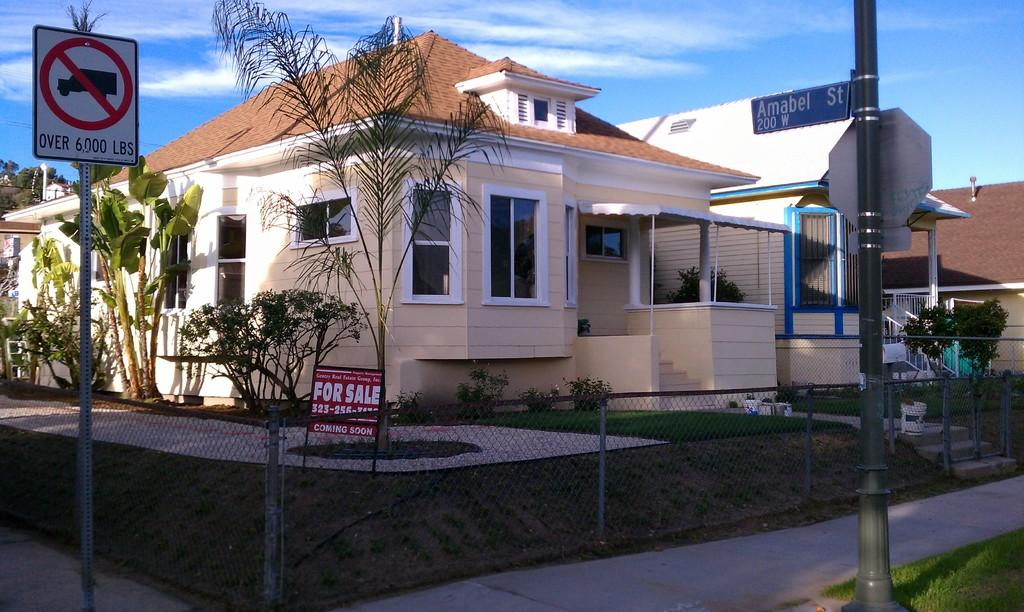<image>
Present a compact description of the photo's key features. a beige house on Amabel St with a For Sale sign out front 